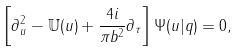Convert formula to latex. <formula><loc_0><loc_0><loc_500><loc_500>\left [ \partial ^ { 2 } _ { u } - \mathbb { U } ( u ) + \frac { 4 i } { \pi b ^ { 2 } } \partial _ { \tau } \right ] \Psi ( u | q ) = 0 ,</formula> 